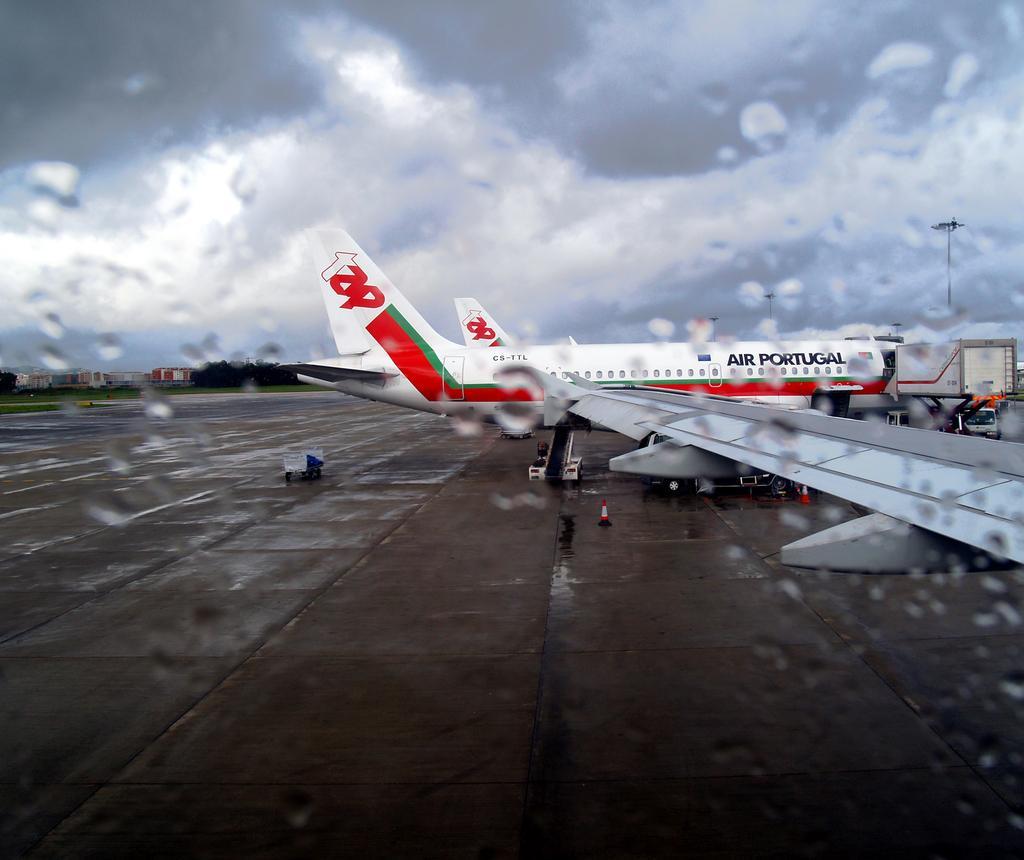Can you describe this image briefly? In this picture we can see an airplane, airplane wing, vehicles and traffic cones on the surface. In the background of the image we can see trees, buildings and sky with clouds. 